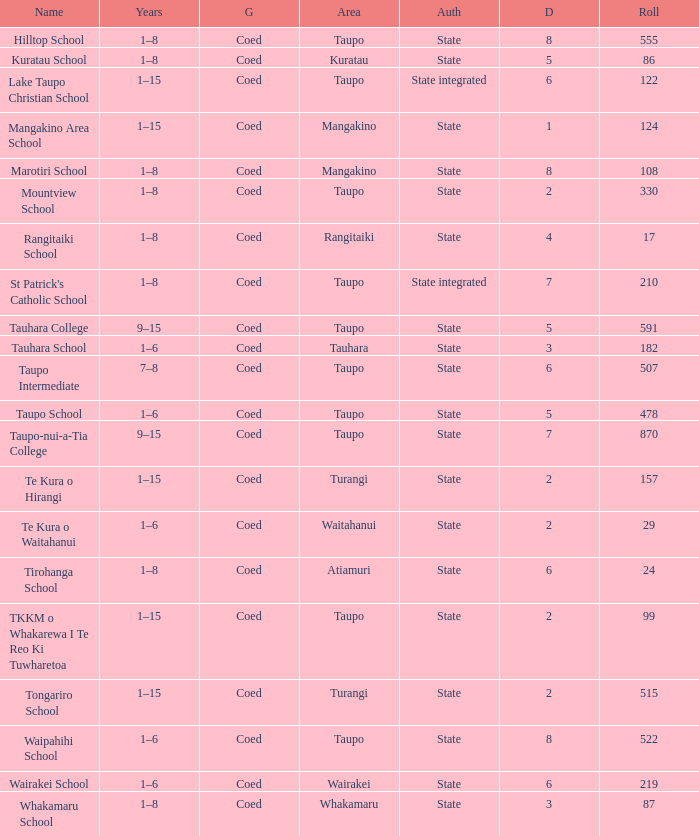Where is the school with state authority that has a roll of more than 157 students? Taupo, Taupo, Taupo, Tauhara, Taupo, Taupo, Taupo, Turangi, Taupo, Wairakei. 